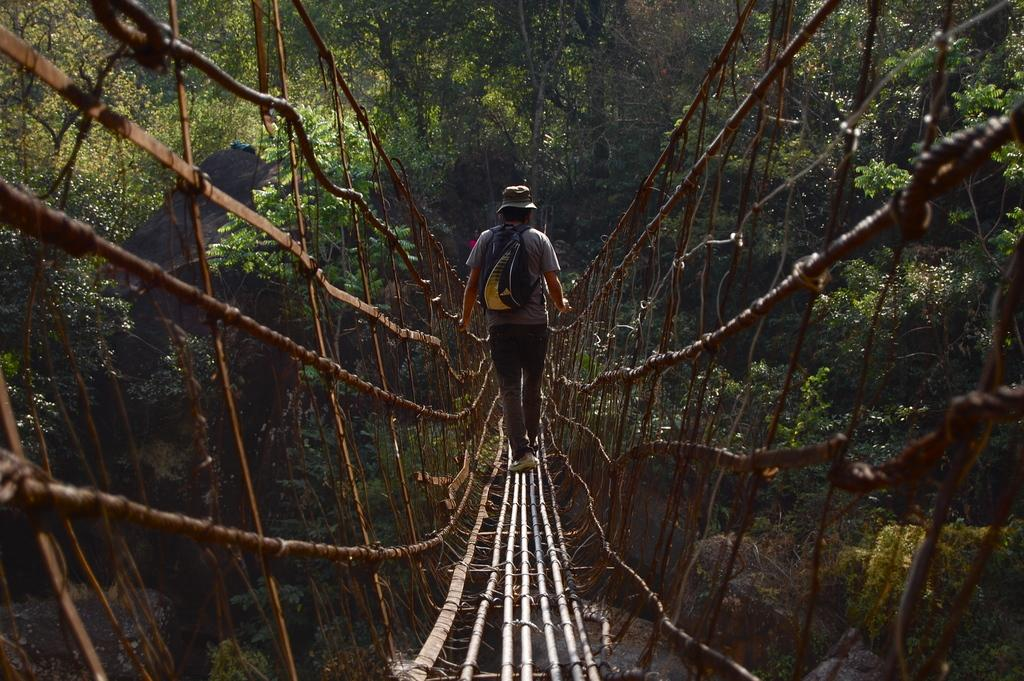What is the main subject of the image? The main subject of the image is a man. What is the man wearing in the image? The man is wearing a grey T-shirt in the image. What type of bridge is the man walking on? The man is walking on a living root bridge or a rope bridge in the image. What can be seen in the background of the image? There are trees in the background of the image. What type of milk can be seen in the image? There is no milk present in the image. Is there a donkey visible in the image? No, there is no donkey present in the image. 